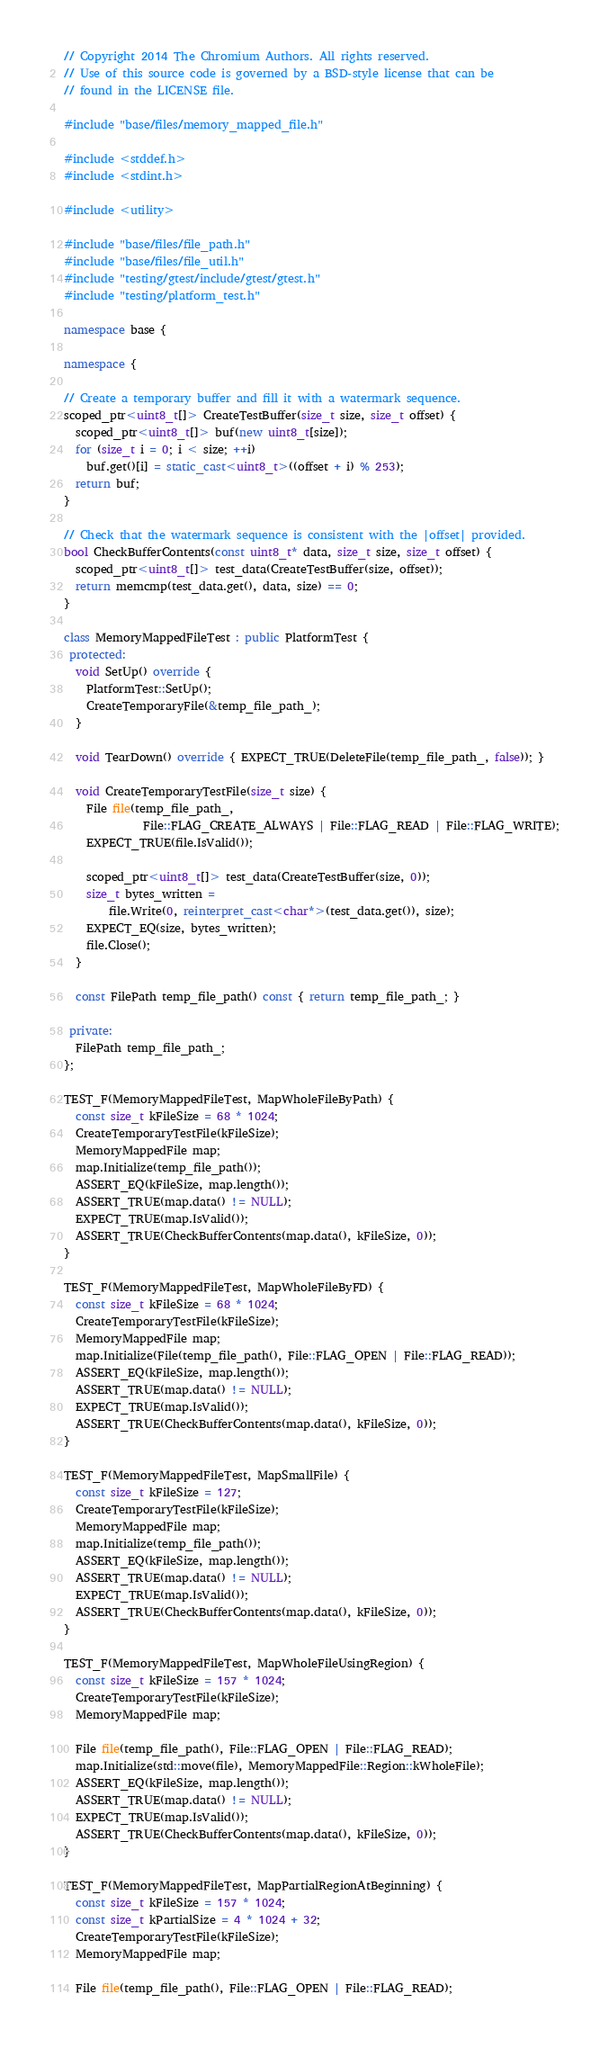Convert code to text. <code><loc_0><loc_0><loc_500><loc_500><_C++_>// Copyright 2014 The Chromium Authors. All rights reserved.
// Use of this source code is governed by a BSD-style license that can be
// found in the LICENSE file.

#include "base/files/memory_mapped_file.h"

#include <stddef.h>
#include <stdint.h>

#include <utility>

#include "base/files/file_path.h"
#include "base/files/file_util.h"
#include "testing/gtest/include/gtest/gtest.h"
#include "testing/platform_test.h"

namespace base {

namespace {

// Create a temporary buffer and fill it with a watermark sequence.
scoped_ptr<uint8_t[]> CreateTestBuffer(size_t size, size_t offset) {
  scoped_ptr<uint8_t[]> buf(new uint8_t[size]);
  for (size_t i = 0; i < size; ++i)
    buf.get()[i] = static_cast<uint8_t>((offset + i) % 253);
  return buf;
}

// Check that the watermark sequence is consistent with the |offset| provided.
bool CheckBufferContents(const uint8_t* data, size_t size, size_t offset) {
  scoped_ptr<uint8_t[]> test_data(CreateTestBuffer(size, offset));
  return memcmp(test_data.get(), data, size) == 0;
}

class MemoryMappedFileTest : public PlatformTest {
 protected:
  void SetUp() override {
    PlatformTest::SetUp();
    CreateTemporaryFile(&temp_file_path_);
  }

  void TearDown() override { EXPECT_TRUE(DeleteFile(temp_file_path_, false)); }

  void CreateTemporaryTestFile(size_t size) {
    File file(temp_file_path_,
              File::FLAG_CREATE_ALWAYS | File::FLAG_READ | File::FLAG_WRITE);
    EXPECT_TRUE(file.IsValid());

    scoped_ptr<uint8_t[]> test_data(CreateTestBuffer(size, 0));
    size_t bytes_written =
        file.Write(0, reinterpret_cast<char*>(test_data.get()), size);
    EXPECT_EQ(size, bytes_written);
    file.Close();
  }

  const FilePath temp_file_path() const { return temp_file_path_; }

 private:
  FilePath temp_file_path_;
};

TEST_F(MemoryMappedFileTest, MapWholeFileByPath) {
  const size_t kFileSize = 68 * 1024;
  CreateTemporaryTestFile(kFileSize);
  MemoryMappedFile map;
  map.Initialize(temp_file_path());
  ASSERT_EQ(kFileSize, map.length());
  ASSERT_TRUE(map.data() != NULL);
  EXPECT_TRUE(map.IsValid());
  ASSERT_TRUE(CheckBufferContents(map.data(), kFileSize, 0));
}

TEST_F(MemoryMappedFileTest, MapWholeFileByFD) {
  const size_t kFileSize = 68 * 1024;
  CreateTemporaryTestFile(kFileSize);
  MemoryMappedFile map;
  map.Initialize(File(temp_file_path(), File::FLAG_OPEN | File::FLAG_READ));
  ASSERT_EQ(kFileSize, map.length());
  ASSERT_TRUE(map.data() != NULL);
  EXPECT_TRUE(map.IsValid());
  ASSERT_TRUE(CheckBufferContents(map.data(), kFileSize, 0));
}

TEST_F(MemoryMappedFileTest, MapSmallFile) {
  const size_t kFileSize = 127;
  CreateTemporaryTestFile(kFileSize);
  MemoryMappedFile map;
  map.Initialize(temp_file_path());
  ASSERT_EQ(kFileSize, map.length());
  ASSERT_TRUE(map.data() != NULL);
  EXPECT_TRUE(map.IsValid());
  ASSERT_TRUE(CheckBufferContents(map.data(), kFileSize, 0));
}

TEST_F(MemoryMappedFileTest, MapWholeFileUsingRegion) {
  const size_t kFileSize = 157 * 1024;
  CreateTemporaryTestFile(kFileSize);
  MemoryMappedFile map;

  File file(temp_file_path(), File::FLAG_OPEN | File::FLAG_READ);
  map.Initialize(std::move(file), MemoryMappedFile::Region::kWholeFile);
  ASSERT_EQ(kFileSize, map.length());
  ASSERT_TRUE(map.data() != NULL);
  EXPECT_TRUE(map.IsValid());
  ASSERT_TRUE(CheckBufferContents(map.data(), kFileSize, 0));
}

TEST_F(MemoryMappedFileTest, MapPartialRegionAtBeginning) {
  const size_t kFileSize = 157 * 1024;
  const size_t kPartialSize = 4 * 1024 + 32;
  CreateTemporaryTestFile(kFileSize);
  MemoryMappedFile map;

  File file(temp_file_path(), File::FLAG_OPEN | File::FLAG_READ);</code> 